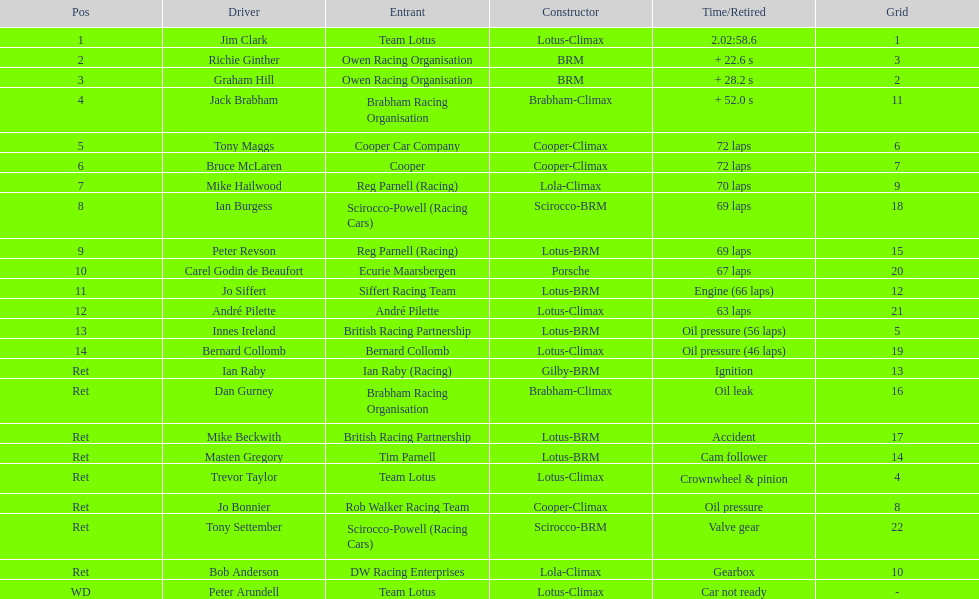Who came in first? Jim Clark. 